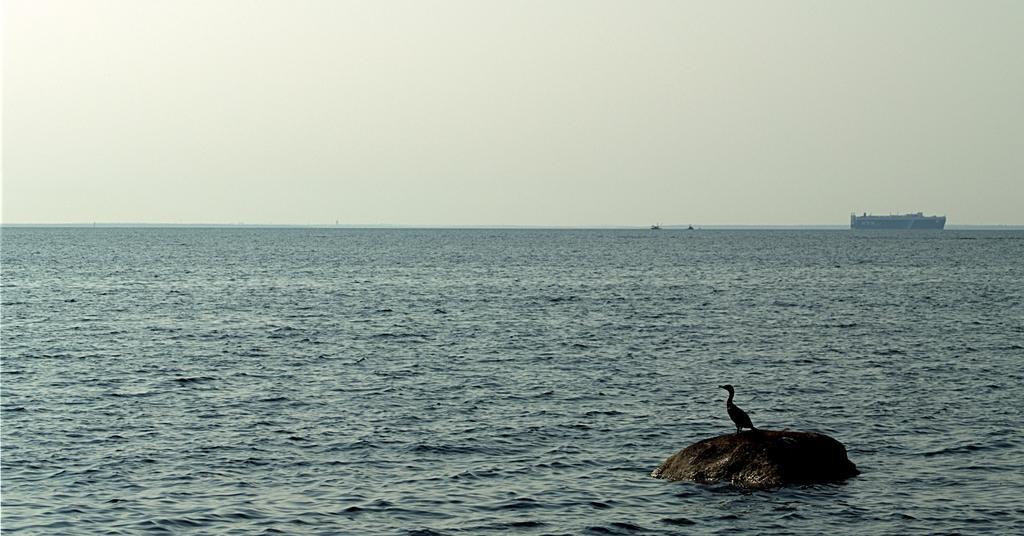Can you describe this image briefly? In this image there is the sea, on which there is a boat and a bird visible on stone, at the top there is the sky. 